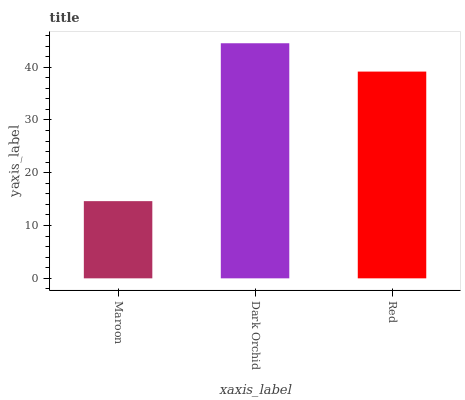Is Maroon the minimum?
Answer yes or no. Yes. Is Dark Orchid the maximum?
Answer yes or no. Yes. Is Red the minimum?
Answer yes or no. No. Is Red the maximum?
Answer yes or no. No. Is Dark Orchid greater than Red?
Answer yes or no. Yes. Is Red less than Dark Orchid?
Answer yes or no. Yes. Is Red greater than Dark Orchid?
Answer yes or no. No. Is Dark Orchid less than Red?
Answer yes or no. No. Is Red the high median?
Answer yes or no. Yes. Is Red the low median?
Answer yes or no. Yes. Is Dark Orchid the high median?
Answer yes or no. No. Is Maroon the low median?
Answer yes or no. No. 